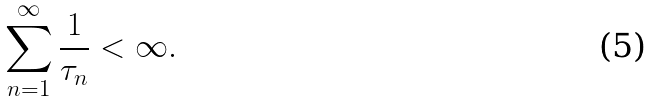Convert formula to latex. <formula><loc_0><loc_0><loc_500><loc_500>\sum _ { n = 1 } ^ { \infty } \frac { 1 } { \tau _ { n } } < \infty .</formula> 